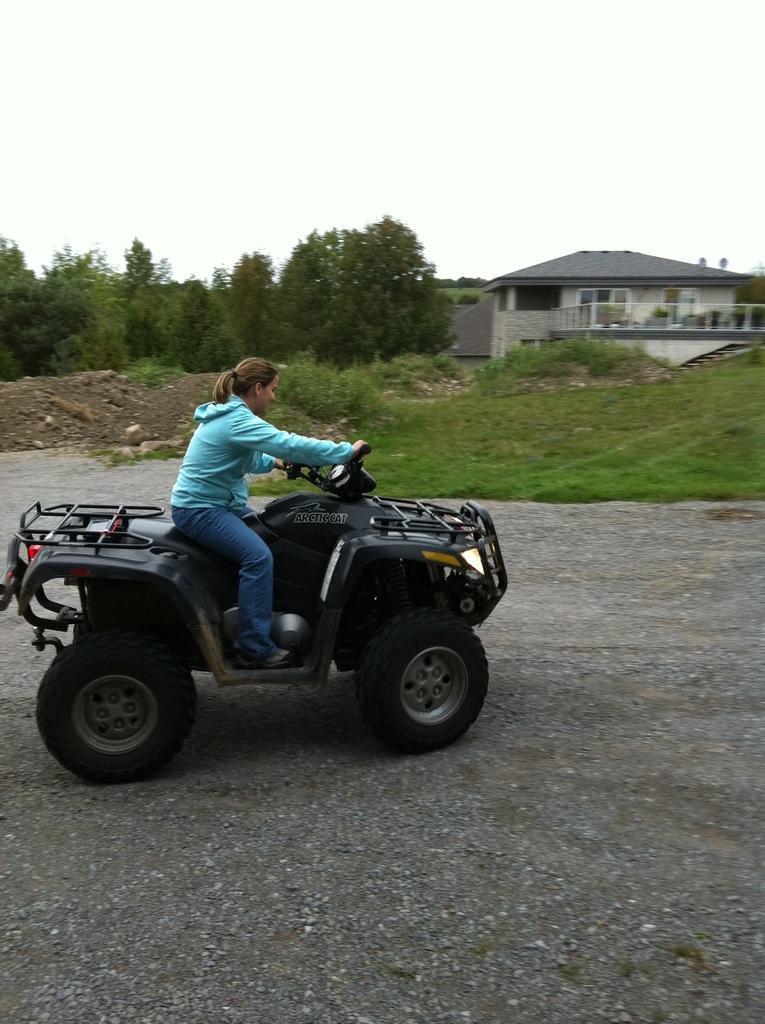Can you describe this image briefly? In the image we can see a woman wearing clothes and the woman is sitting on the vehicle. Here we can see the road, grass, trees and the sky. We can even see the house. 